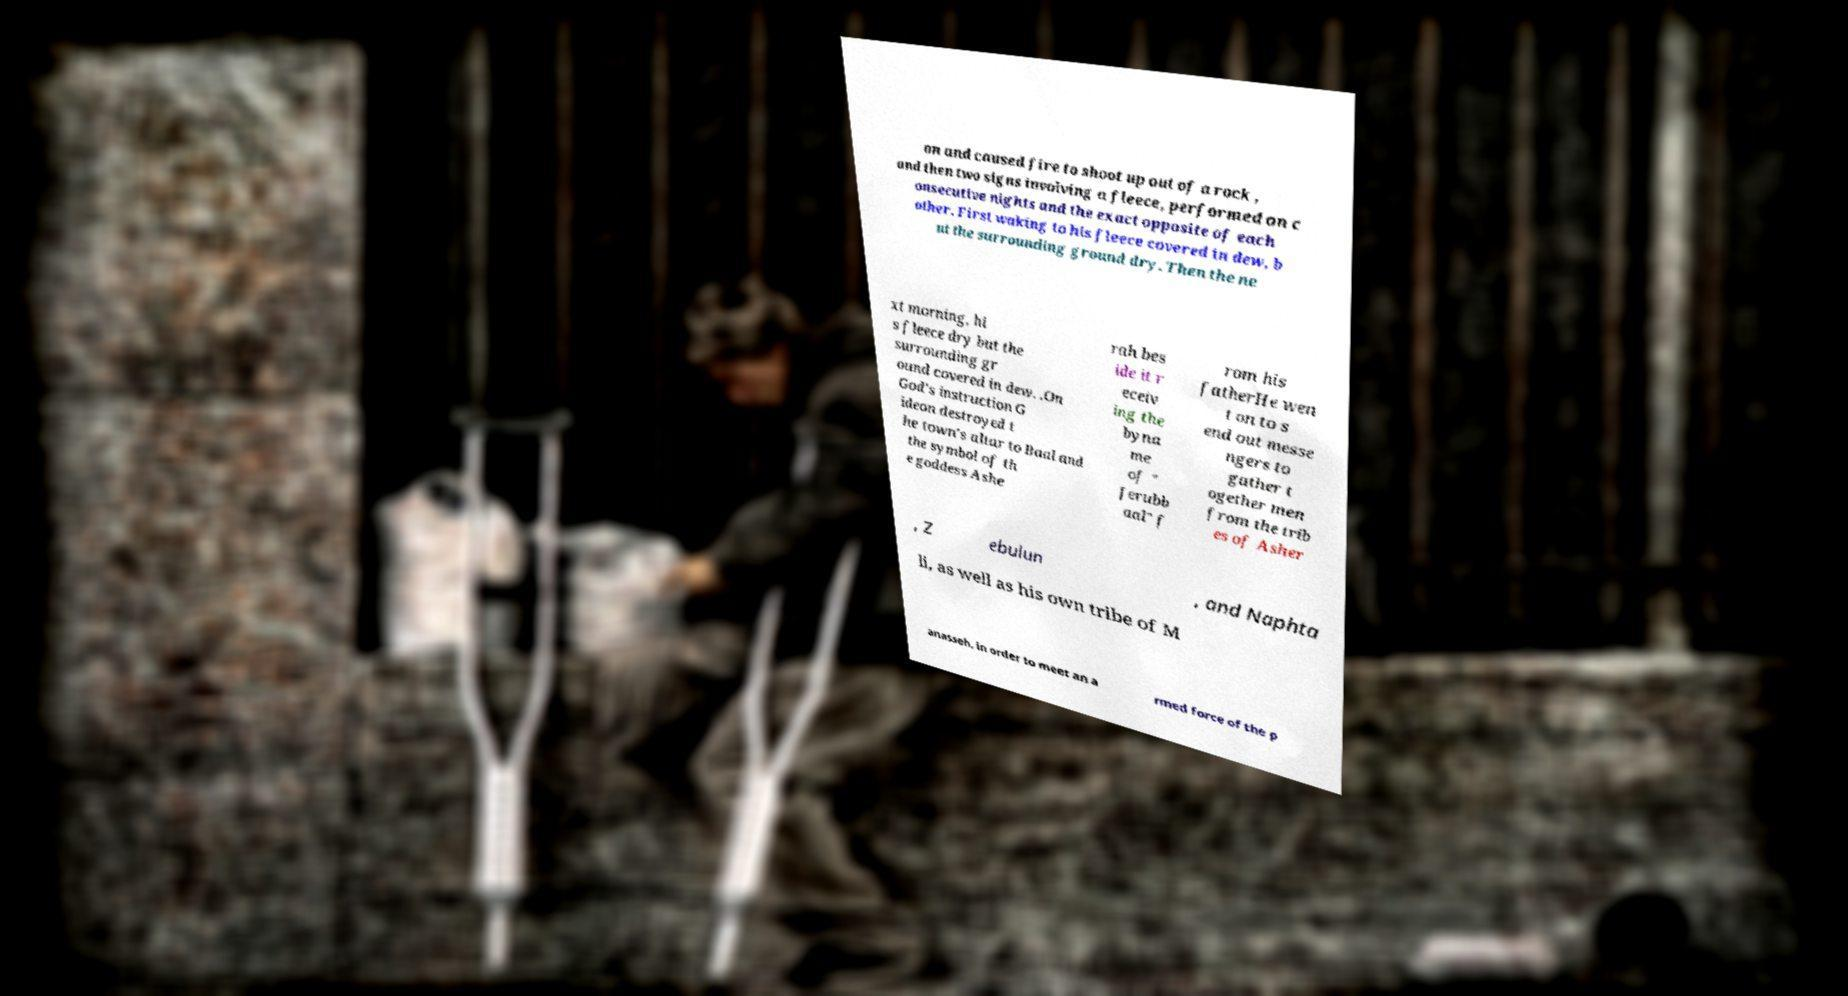There's text embedded in this image that I need extracted. Can you transcribe it verbatim? on and caused fire to shoot up out of a rock , and then two signs involving a fleece, performed on c onsecutive nights and the exact opposite of each other. First waking to his fleece covered in dew, b ut the surrounding ground dry. Then the ne xt morning, hi s fleece dry but the surrounding gr ound covered in dew. .On God's instruction G ideon destroyed t he town's altar to Baal and the symbol of th e goddess Ashe rah bes ide it r eceiv ing the byna me of " Jerubb aal" f rom his fatherHe wen t on to s end out messe ngers to gather t ogether men from the trib es of Asher , Z ebulun , and Naphta li, as well as his own tribe of M anasseh, in order to meet an a rmed force of the p 